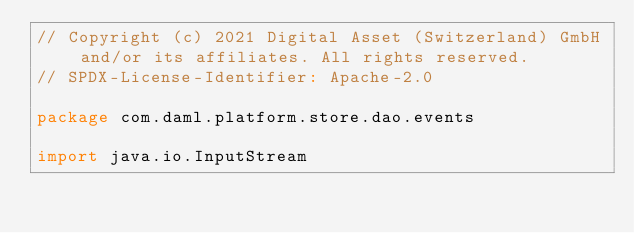Convert code to text. <code><loc_0><loc_0><loc_500><loc_500><_Scala_>// Copyright (c) 2021 Digital Asset (Switzerland) GmbH and/or its affiliates. All rights reserved.
// SPDX-License-Identifier: Apache-2.0

package com.daml.platform.store.dao.events

import java.io.InputStream
</code> 